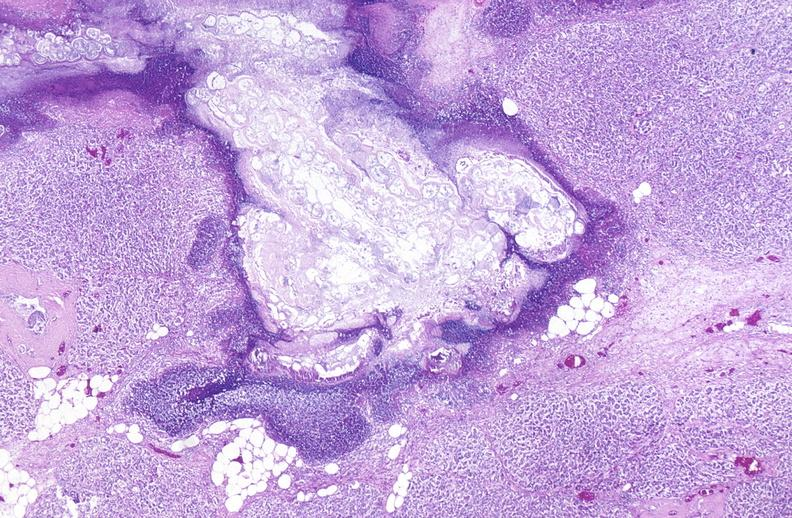does side show pancreatic fat necrosis?
Answer the question using a single word or phrase. No 